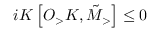Convert formula to latex. <formula><loc_0><loc_0><loc_500><loc_500>i K \left [ O _ { > } K , \tilde { M } _ { > } \right ] \leq 0</formula> 